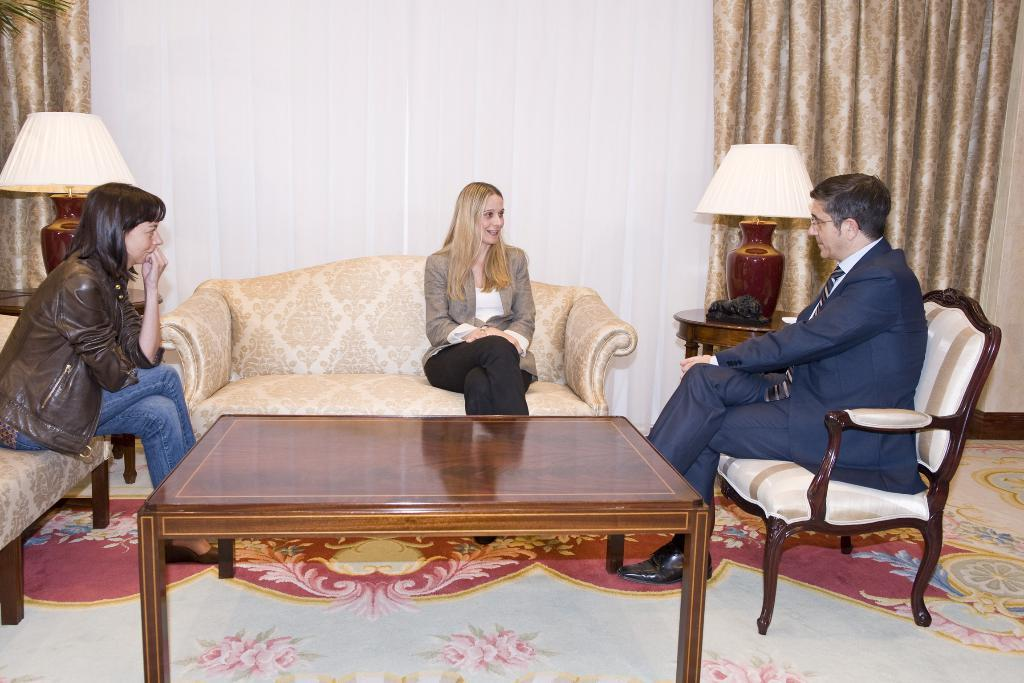How many people are sitting on the sofa in the image? There are three persons sitting on the sofa in the image. What other furniture can be seen in the image? There is a table in the image. What type of lighting is present in the image? There are lamps in the image. What is visible in the background of the image? There is a wall in the background of the image. What type of window treatment is present in the image? There is a curtain in the image. What type of surface is visible under the furniture? There is a floor visible in the image. What type of beast is hiding behind the curtain in the image? There is no beast present in the image; it only features three persons sitting on the sofa, a table, lamps, a wall, a curtain, and a floor. 